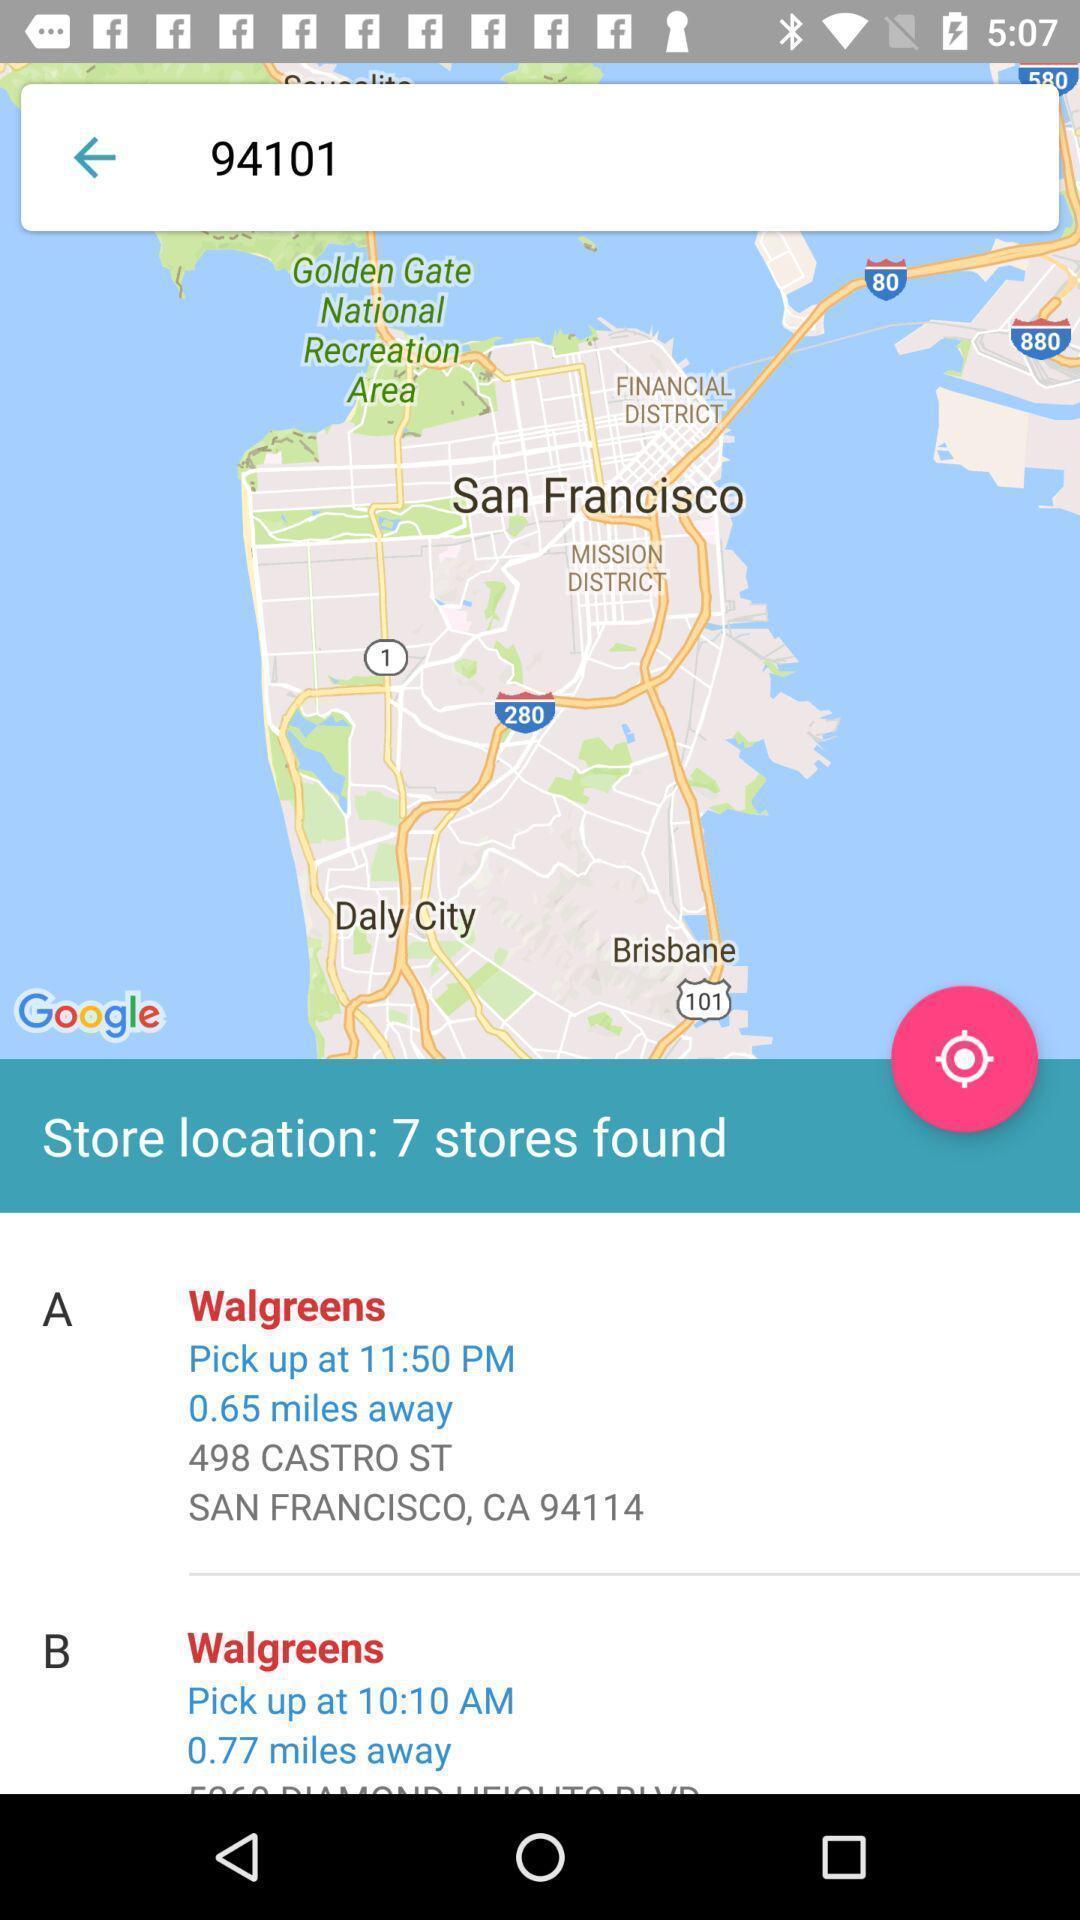Give me a narrative description of this picture. Search page of a location finder. 